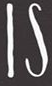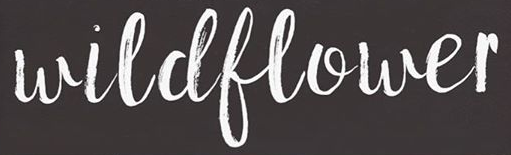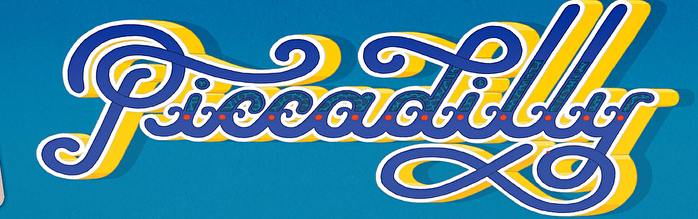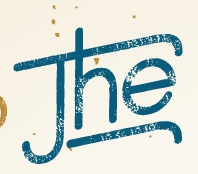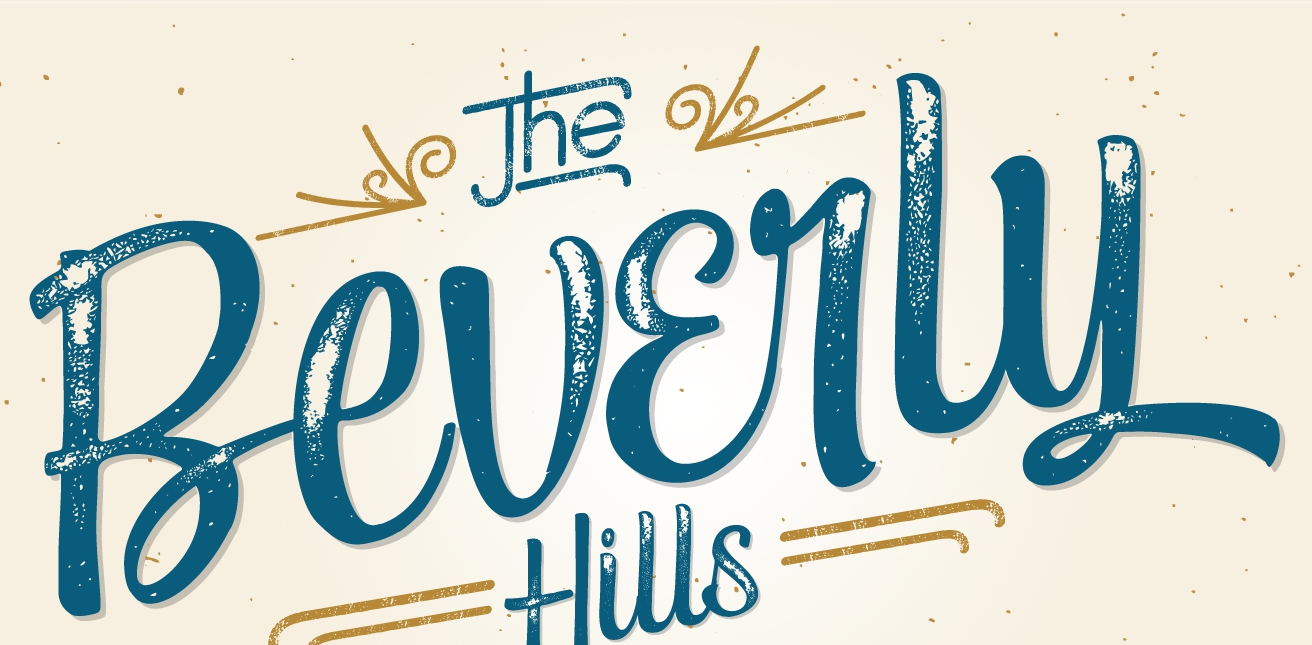What words are shown in these images in order, separated by a semicolon? IS; wildflower; Piccadilly; The; Beverly 